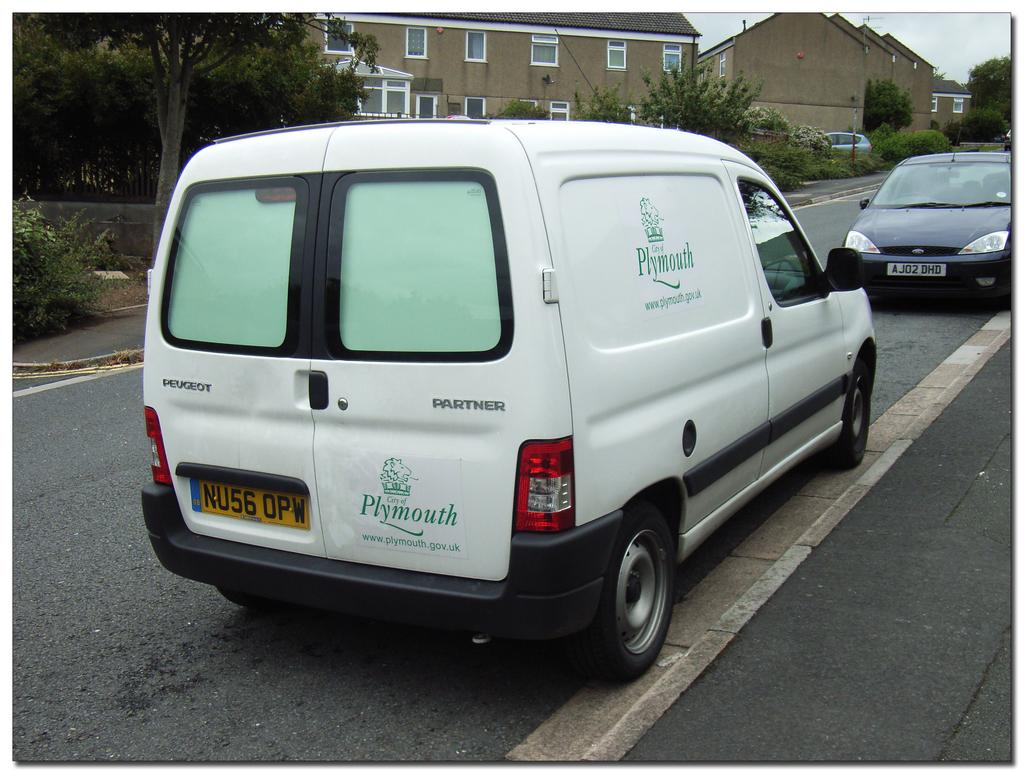<image>
Provide a brief description of the given image. A white van from the City of Plymouth. 